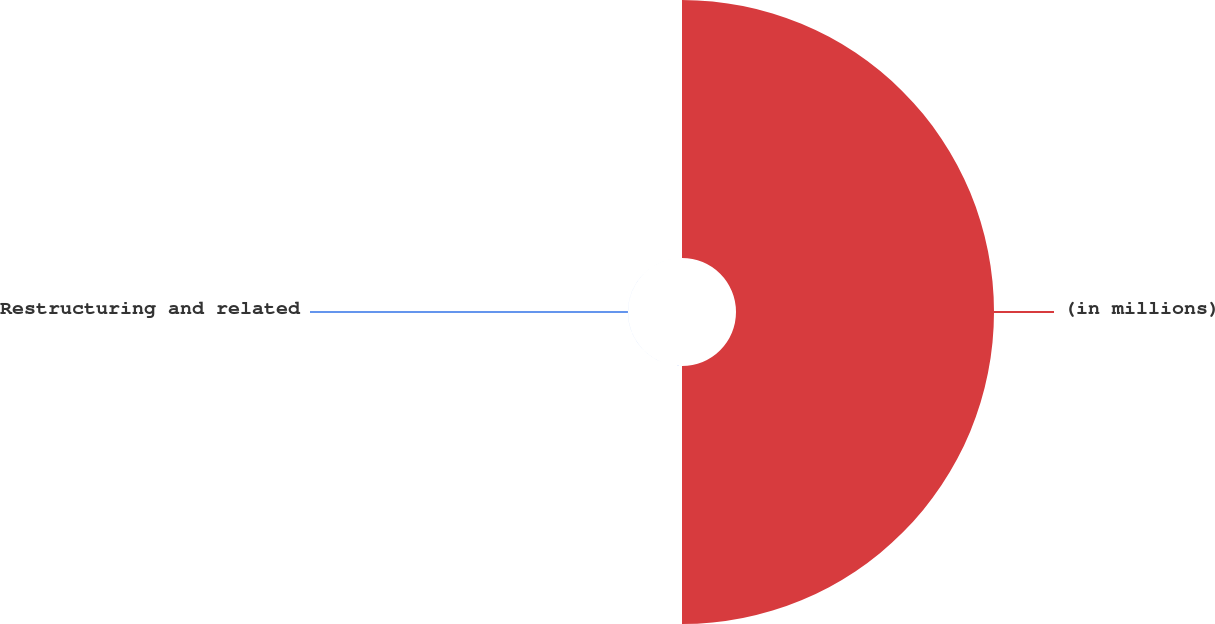Convert chart. <chart><loc_0><loc_0><loc_500><loc_500><pie_chart><fcel>(in millions)<fcel>Restructuring and related<nl><fcel>99.98%<fcel>0.02%<nl></chart> 